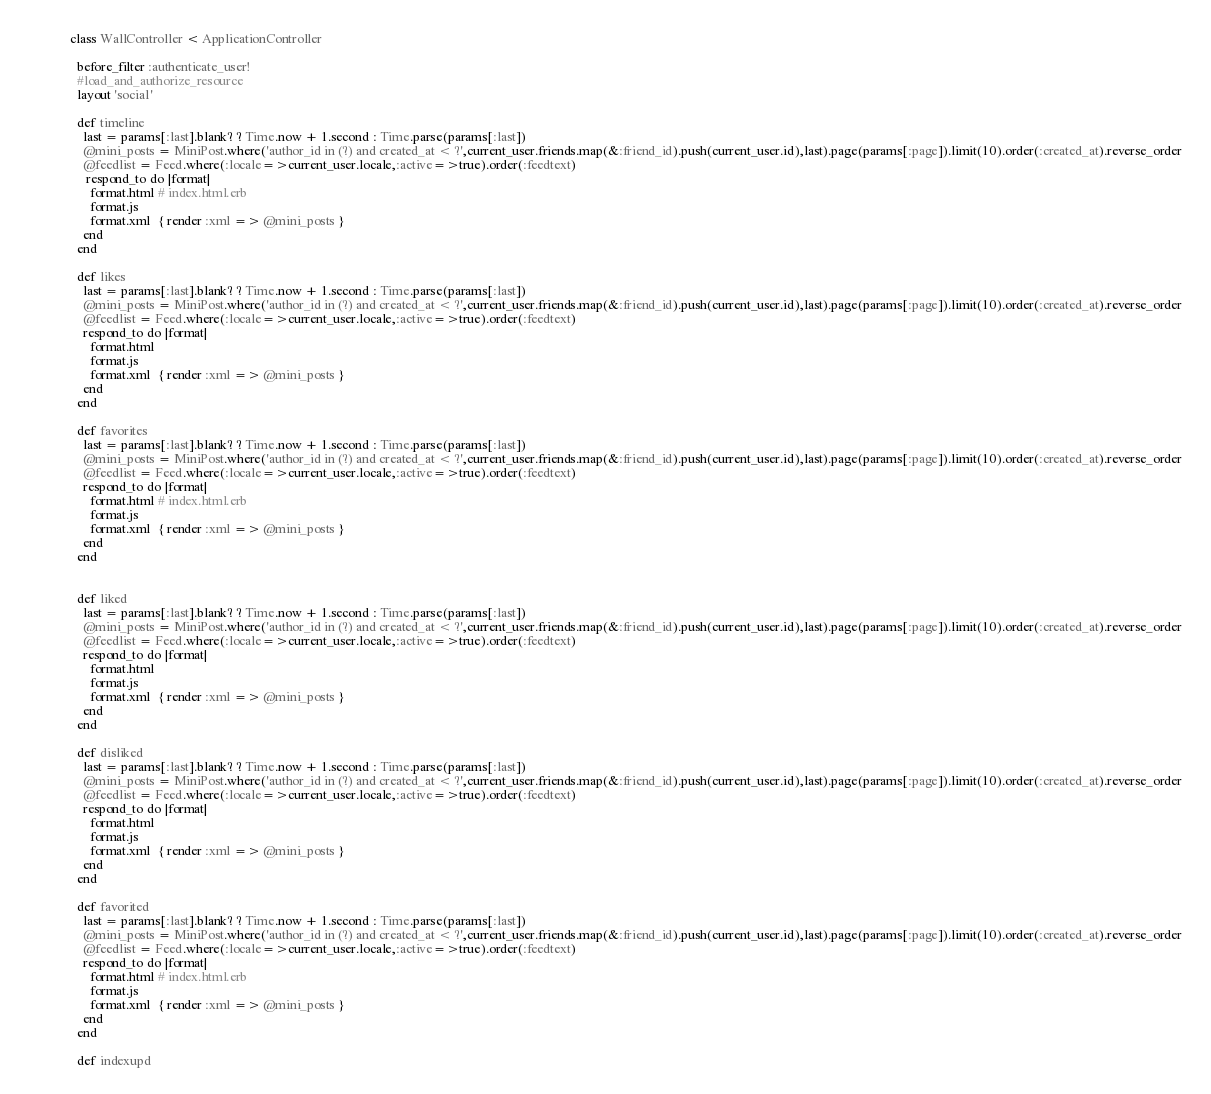<code> <loc_0><loc_0><loc_500><loc_500><_Ruby_>class WallController < ApplicationController
  
  before_filter :authenticate_user!
  #load_and_authorize_resource
  layout 'social'

  def timeline
    last = params[:last].blank? ? Time.now + 1.second : Time.parse(params[:last])
    @mini_posts = MiniPost.where('author_id in (?) and created_at < ?',current_user.friends.map(&:friend_id).push(current_user.id),last).page(params[:page]).limit(10).order(:created_at).reverse_order
    @feedlist = Feed.where(:locale=>current_user.locale,:active=>true).order(:feedtext)
     respond_to do |format|
      format.html # index.html.erb
      format.js
      format.xml  { render :xml => @mini_posts }
    end
  end

  def likes
    last = params[:last].blank? ? Time.now + 1.second : Time.parse(params[:last])
    @mini_posts = MiniPost.where('author_id in (?) and created_at < ?',current_user.friends.map(&:friend_id).push(current_user.id),last).page(params[:page]).limit(10).order(:created_at).reverse_order
    @feedlist = Feed.where(:locale=>current_user.locale,:active=>true).order(:feedtext)
    respond_to do |format|
      format.html
      format.js
      format.xml  { render :xml => @mini_posts }
    end
  end

  def favorites
    last = params[:last].blank? ? Time.now + 1.second : Time.parse(params[:last])
    @mini_posts = MiniPost.where('author_id in (?) and created_at < ?',current_user.friends.map(&:friend_id).push(current_user.id),last).page(params[:page]).limit(10).order(:created_at).reverse_order
    @feedlist = Feed.where(:locale=>current_user.locale,:active=>true).order(:feedtext)
    respond_to do |format|
      format.html # index.html.erb
      format.js
      format.xml  { render :xml => @mini_posts }
    end
  end


  def liked
    last = params[:last].blank? ? Time.now + 1.second : Time.parse(params[:last])
    @mini_posts = MiniPost.where('author_id in (?) and created_at < ?',current_user.friends.map(&:friend_id).push(current_user.id),last).page(params[:page]).limit(10).order(:created_at).reverse_order
    @feedlist = Feed.where(:locale=>current_user.locale,:active=>true).order(:feedtext)
    respond_to do |format|
      format.html
      format.js
      format.xml  { render :xml => @mini_posts }
    end
  end

  def disliked
    last = params[:last].blank? ? Time.now + 1.second : Time.parse(params[:last])
    @mini_posts = MiniPost.where('author_id in (?) and created_at < ?',current_user.friends.map(&:friend_id).push(current_user.id),last).page(params[:page]).limit(10).order(:created_at).reverse_order
    @feedlist = Feed.where(:locale=>current_user.locale,:active=>true).order(:feedtext)
    respond_to do |format|
      format.html
      format.js
      format.xml  { render :xml => @mini_posts }
    end
  end

  def favorited
    last = params[:last].blank? ? Time.now + 1.second : Time.parse(params[:last])
    @mini_posts = MiniPost.where('author_id in (?) and created_at < ?',current_user.friends.map(&:friend_id).push(current_user.id),last).page(params[:page]).limit(10).order(:created_at).reverse_order
    @feedlist = Feed.where(:locale=>current_user.locale,:active=>true).order(:feedtext)
    respond_to do |format|
      format.html # index.html.erb
      format.js
      format.xml  { render :xml => @mini_posts }
    end
  end

  def indexupd</code> 